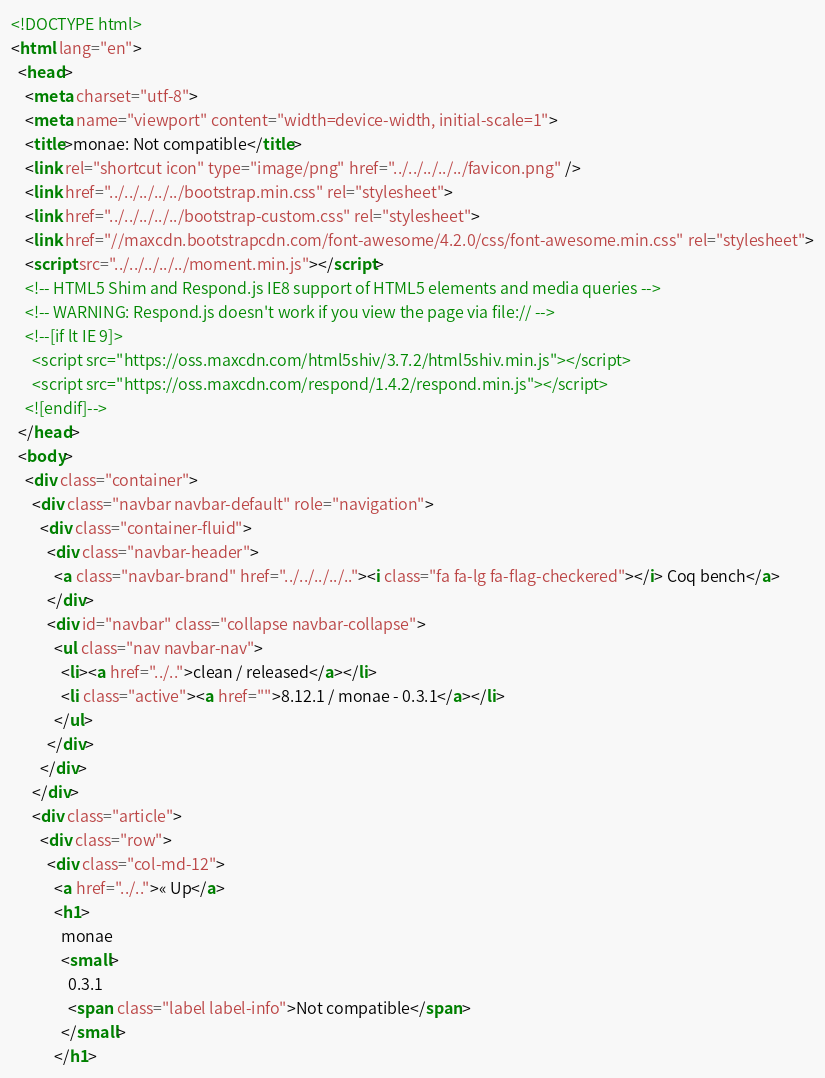Convert code to text. <code><loc_0><loc_0><loc_500><loc_500><_HTML_><!DOCTYPE html>
<html lang="en">
  <head>
    <meta charset="utf-8">
    <meta name="viewport" content="width=device-width, initial-scale=1">
    <title>monae: Not compatible</title>
    <link rel="shortcut icon" type="image/png" href="../../../../../favicon.png" />
    <link href="../../../../../bootstrap.min.css" rel="stylesheet">
    <link href="../../../../../bootstrap-custom.css" rel="stylesheet">
    <link href="//maxcdn.bootstrapcdn.com/font-awesome/4.2.0/css/font-awesome.min.css" rel="stylesheet">
    <script src="../../../../../moment.min.js"></script>
    <!-- HTML5 Shim and Respond.js IE8 support of HTML5 elements and media queries -->
    <!-- WARNING: Respond.js doesn't work if you view the page via file:// -->
    <!--[if lt IE 9]>
      <script src="https://oss.maxcdn.com/html5shiv/3.7.2/html5shiv.min.js"></script>
      <script src="https://oss.maxcdn.com/respond/1.4.2/respond.min.js"></script>
    <![endif]-->
  </head>
  <body>
    <div class="container">
      <div class="navbar navbar-default" role="navigation">
        <div class="container-fluid">
          <div class="navbar-header">
            <a class="navbar-brand" href="../../../../.."><i class="fa fa-lg fa-flag-checkered"></i> Coq bench</a>
          </div>
          <div id="navbar" class="collapse navbar-collapse">
            <ul class="nav navbar-nav">
              <li><a href="../..">clean / released</a></li>
              <li class="active"><a href="">8.12.1 / monae - 0.3.1</a></li>
            </ul>
          </div>
        </div>
      </div>
      <div class="article">
        <div class="row">
          <div class="col-md-12">
            <a href="../..">« Up</a>
            <h1>
              monae
              <small>
                0.3.1
                <span class="label label-info">Not compatible</span>
              </small>
            </h1></code> 